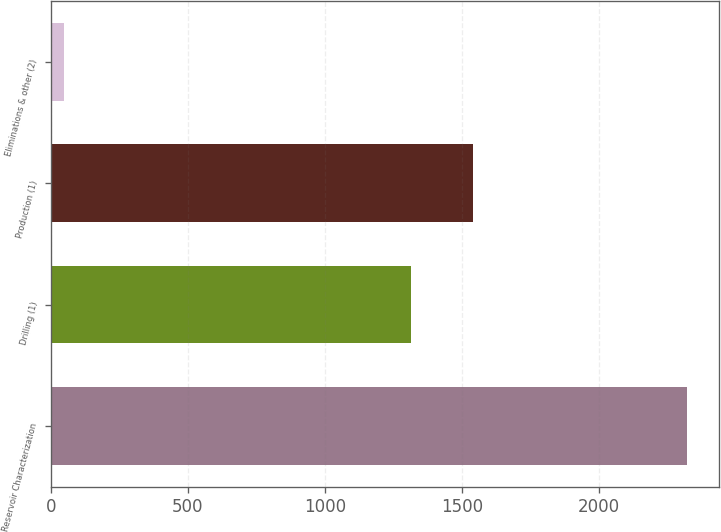<chart> <loc_0><loc_0><loc_500><loc_500><bar_chart><fcel>Reservoir Characterization<fcel>Drilling (1)<fcel>Production (1)<fcel>Eliminations & other (2)<nl><fcel>2321<fcel>1313<fcel>1540.3<fcel>48<nl></chart> 